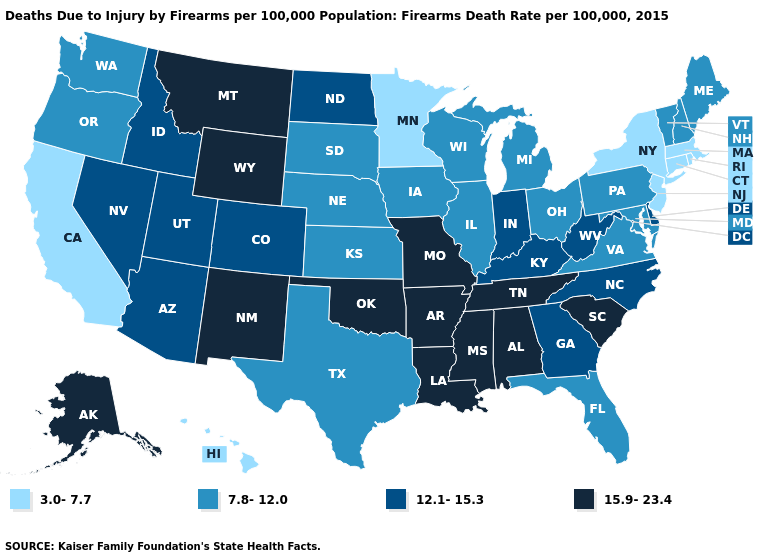Name the states that have a value in the range 15.9-23.4?
Write a very short answer. Alabama, Alaska, Arkansas, Louisiana, Mississippi, Missouri, Montana, New Mexico, Oklahoma, South Carolina, Tennessee, Wyoming. Does the first symbol in the legend represent the smallest category?
Write a very short answer. Yes. What is the lowest value in states that border Nevada?
Write a very short answer. 3.0-7.7. What is the highest value in the South ?
Be succinct. 15.9-23.4. Which states hav the highest value in the MidWest?
Give a very brief answer. Missouri. Does Iowa have the lowest value in the USA?
Be succinct. No. Name the states that have a value in the range 7.8-12.0?
Answer briefly. Florida, Illinois, Iowa, Kansas, Maine, Maryland, Michigan, Nebraska, New Hampshire, Ohio, Oregon, Pennsylvania, South Dakota, Texas, Vermont, Virginia, Washington, Wisconsin. Name the states that have a value in the range 7.8-12.0?
Answer briefly. Florida, Illinois, Iowa, Kansas, Maine, Maryland, Michigan, Nebraska, New Hampshire, Ohio, Oregon, Pennsylvania, South Dakota, Texas, Vermont, Virginia, Washington, Wisconsin. Does Wisconsin have a higher value than Oklahoma?
Be succinct. No. Does Texas have the lowest value in the USA?
Be succinct. No. Which states hav the highest value in the South?
Keep it brief. Alabama, Arkansas, Louisiana, Mississippi, Oklahoma, South Carolina, Tennessee. Among the states that border California , which have the highest value?
Short answer required. Arizona, Nevada. Name the states that have a value in the range 7.8-12.0?
Short answer required. Florida, Illinois, Iowa, Kansas, Maine, Maryland, Michigan, Nebraska, New Hampshire, Ohio, Oregon, Pennsylvania, South Dakota, Texas, Vermont, Virginia, Washington, Wisconsin. Does Ohio have the same value as Montana?
Answer briefly. No. Name the states that have a value in the range 3.0-7.7?
Short answer required. California, Connecticut, Hawaii, Massachusetts, Minnesota, New Jersey, New York, Rhode Island. 